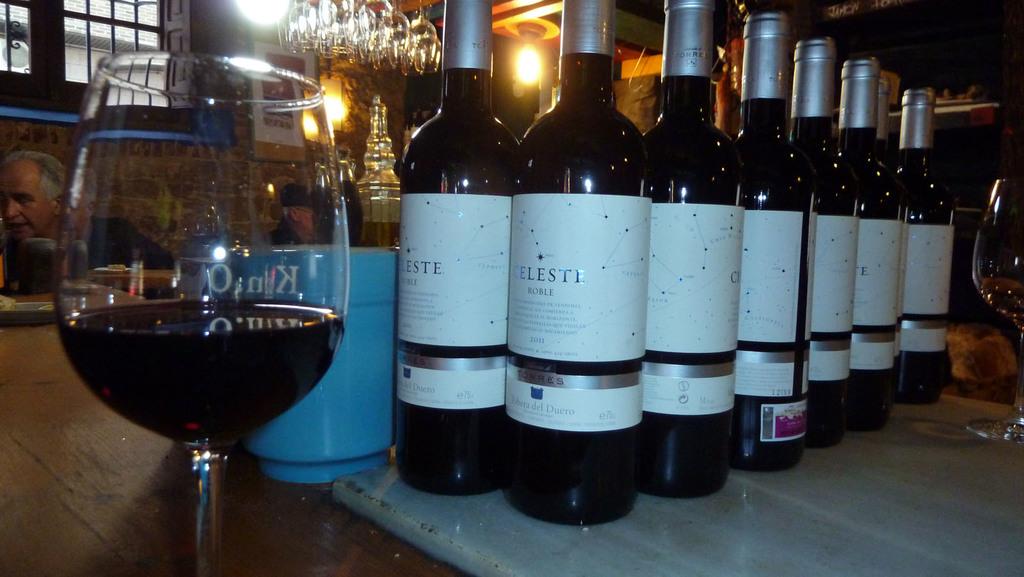What type of wine is this?
Ensure brevity in your answer.  Celeste roble. 